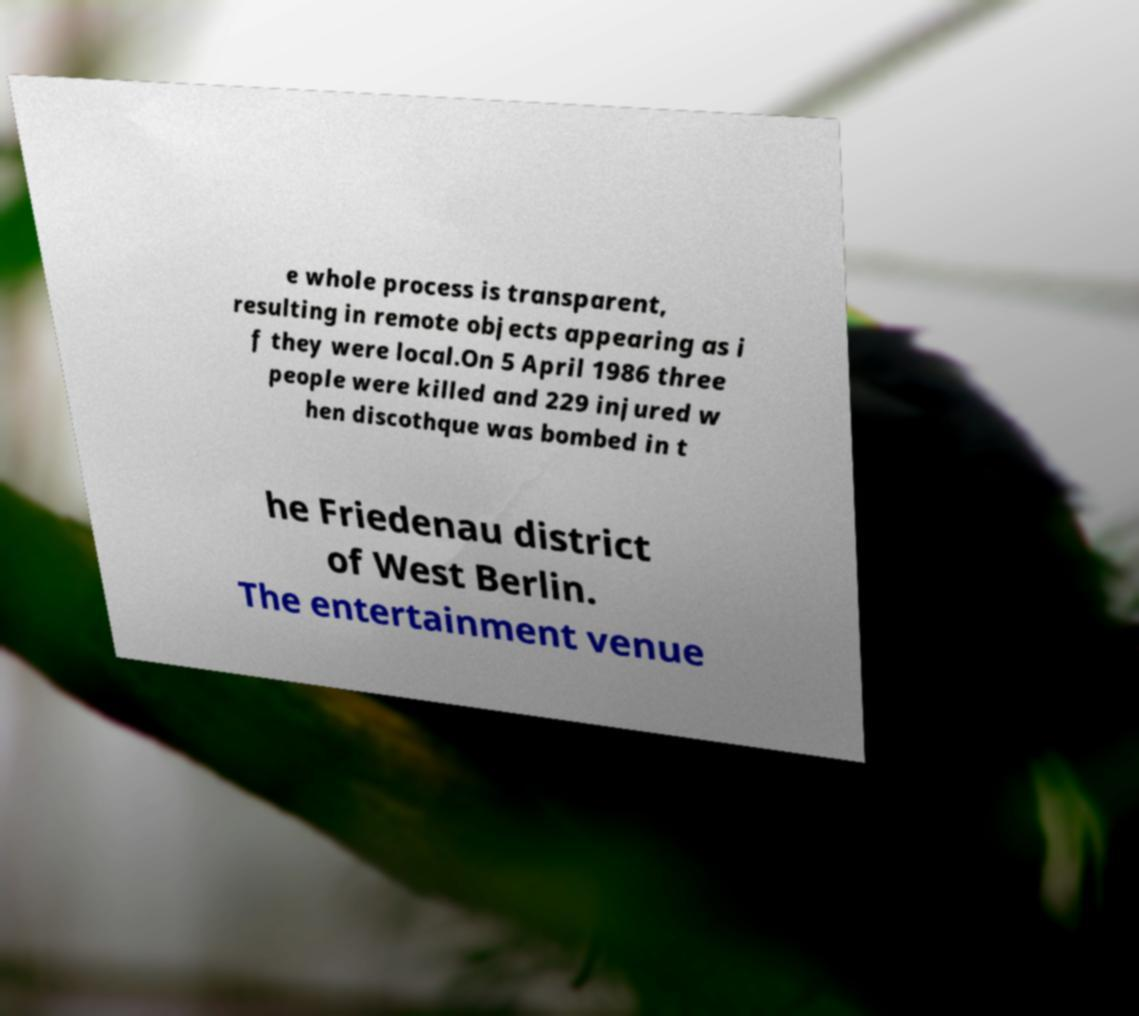Can you read and provide the text displayed in the image?This photo seems to have some interesting text. Can you extract and type it out for me? e whole process is transparent, resulting in remote objects appearing as i f they were local.On 5 April 1986 three people were killed and 229 injured w hen discothque was bombed in t he Friedenau district of West Berlin. The entertainment venue 